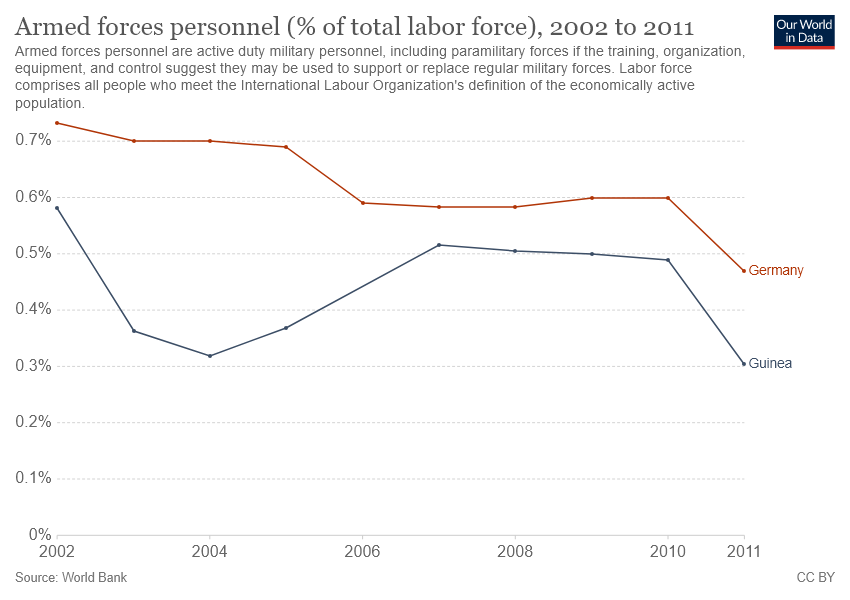Specify some key components in this picture. The country with a higher number of armed forces personnel over the years is Germany, not Guinea. In 2002, the highest percentage of armed forces personnel was recorded in Germany. 